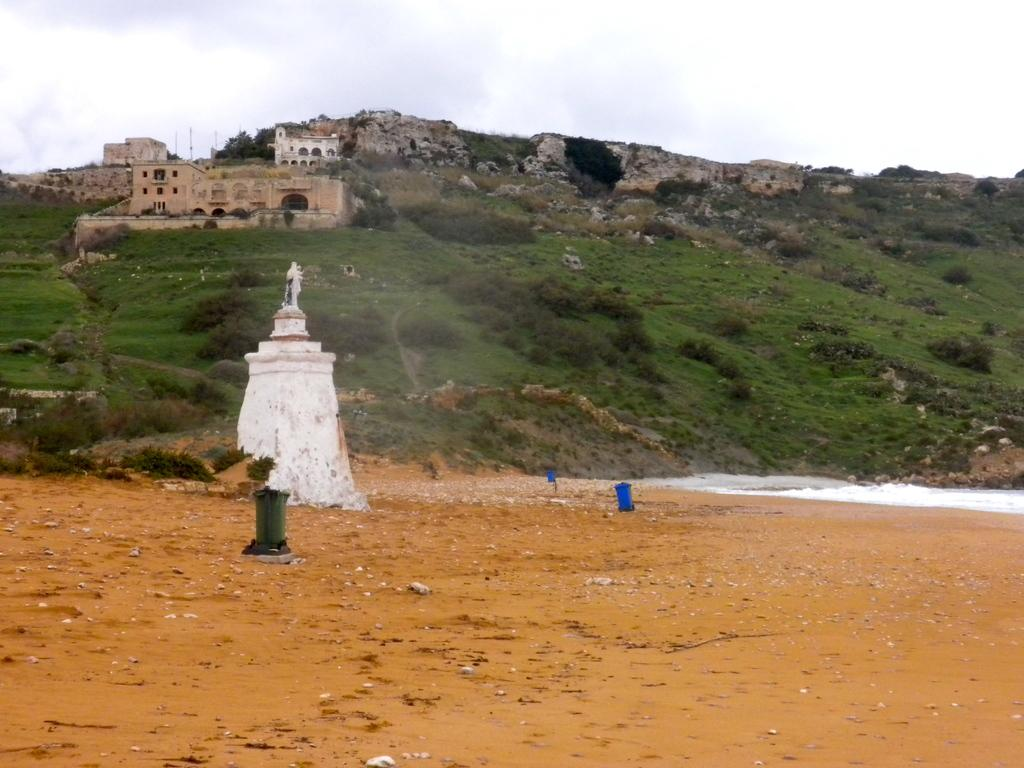What type of landscape feature is present in the image? There is a hill in the image. What type of vegetation can be seen in the image? There is grass and trees in the image. What man-made structure is present in the image? There is a statue and a building in the image. What is visible at the top of the image? The sky is visible at the top of the image. What type of plantation can be seen in the image? There is no plantation present in the image. What is the taste of the statue in the image? The statue is not an edible object and therefore has no taste. 